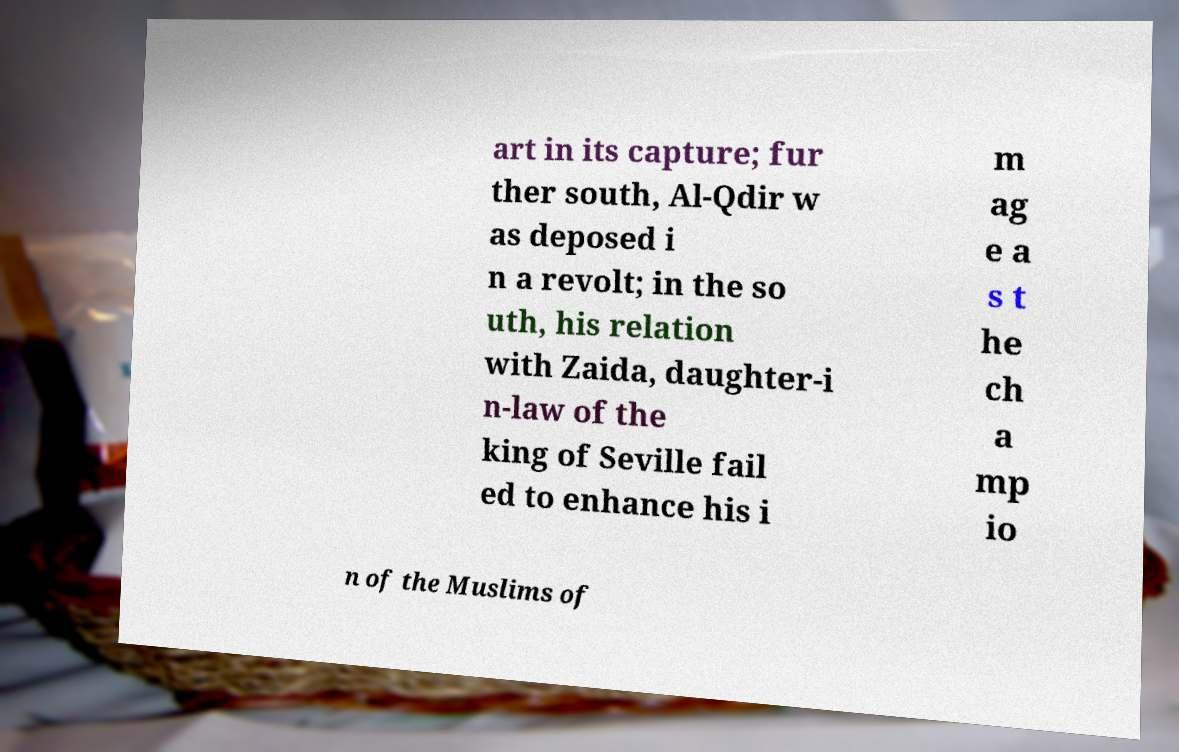Please read and relay the text visible in this image. What does it say? art in its capture; fur ther south, Al-Qdir w as deposed i n a revolt; in the so uth, his relation with Zaida, daughter-i n-law of the king of Seville fail ed to enhance his i m ag e a s t he ch a mp io n of the Muslims of 